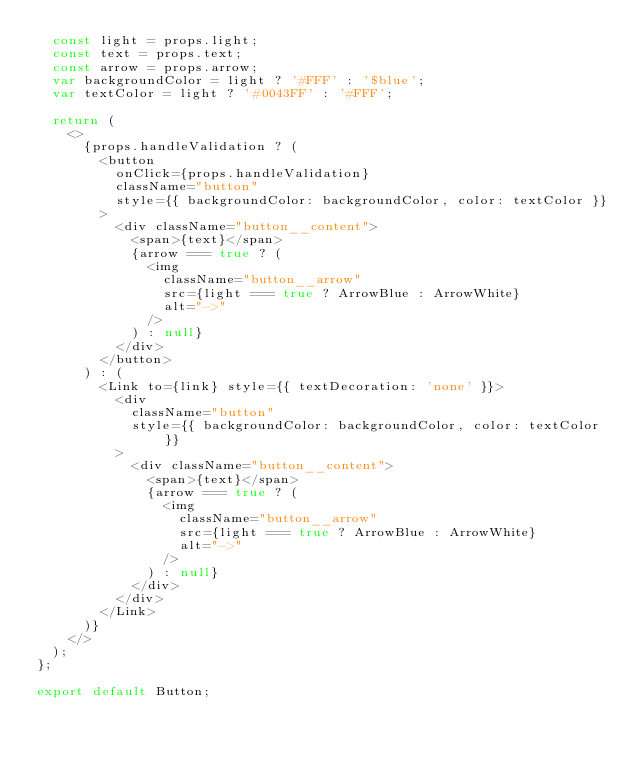<code> <loc_0><loc_0><loc_500><loc_500><_JavaScript_>  const light = props.light;
  const text = props.text;
  const arrow = props.arrow;
  var backgroundColor = light ? '#FFF' : '$blue';
  var textColor = light ? '#0043FF' : '#FFF';

  return (
    <>
      {props.handleValidation ? (
        <button
          onClick={props.handleValidation}
          className="button"
          style={{ backgroundColor: backgroundColor, color: textColor }}
        >
          <div className="button__content">
            <span>{text}</span>
            {arrow === true ? (
              <img
                className="button__arrow"
                src={light === true ? ArrowBlue : ArrowWhite}
                alt="->"
              />
            ) : null}
          </div>
        </button>
      ) : (
        <Link to={link} style={{ textDecoration: 'none' }}>
          <div
            className="button"
            style={{ backgroundColor: backgroundColor, color: textColor }}
          >
            <div className="button__content">
              <span>{text}</span>
              {arrow === true ? (
                <img
                  className="button__arrow"
                  src={light === true ? ArrowBlue : ArrowWhite}
                  alt="->"
                />
              ) : null}
            </div>
          </div>
        </Link>
      )}
    </>
  );
};

export default Button;
</code> 